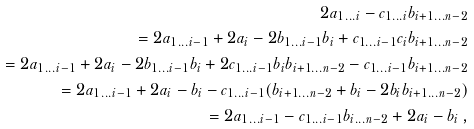<formula> <loc_0><loc_0><loc_500><loc_500>2 a _ { 1 \dots i } - c _ { 1 \dots i } b _ { i + 1 \dots n - 2 } \\ = 2 a _ { 1 \dots i - 1 } + 2 a _ { i } - 2 b _ { 1 \dots i - 1 } b _ { i } + c _ { 1 \dots i - 1 } c _ { i } b _ { i + 1 \dots n - 2 } \\ = 2 a _ { 1 \dots i - 1 } + 2 a _ { i } - 2 b _ { 1 \dots i - 1 } b _ { i } + 2 c _ { 1 \dots i - 1 } b _ { i } b _ { i + 1 \dots n - 2 } - c _ { 1 \dots i - 1 } b _ { i + 1 \dots n - 2 } \\ = 2 a _ { 1 \dots i - 1 } + 2 a _ { i } - b _ { i } - c _ { 1 \dots i - 1 } ( b _ { i + 1 \dots n - 2 } + b _ { i } - 2 b _ { i } b _ { i + 1 \dots n - 2 } ) \\ = 2 a _ { 1 \dots i - 1 } - c _ { 1 \dots i - 1 } b _ { i \dots n - 2 } + 2 a _ { i } - b _ { i } \, ,</formula> 